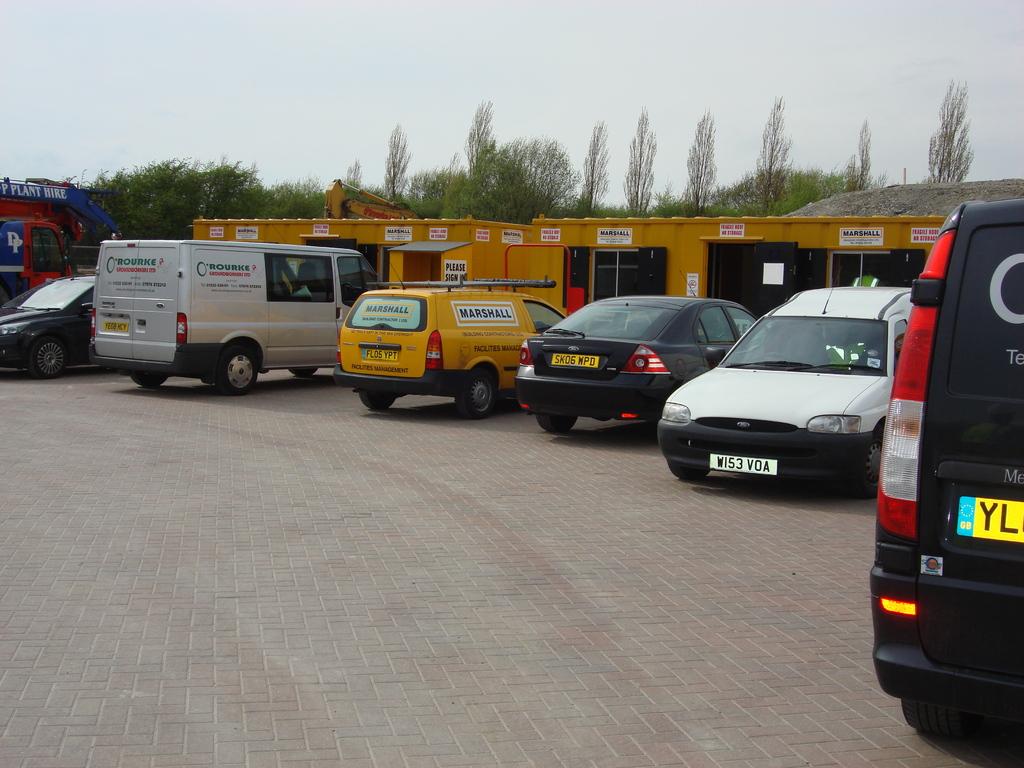What does the white license plate say?
Provide a short and direct response. W153 voa. What are the two letters visable on the black van?
Keep it short and to the point. Yl. 